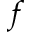<formula> <loc_0><loc_0><loc_500><loc_500>_ { f }</formula> 